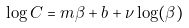<formula> <loc_0><loc_0><loc_500><loc_500>\log C = m \beta + b + \nu \log ( \beta )</formula> 